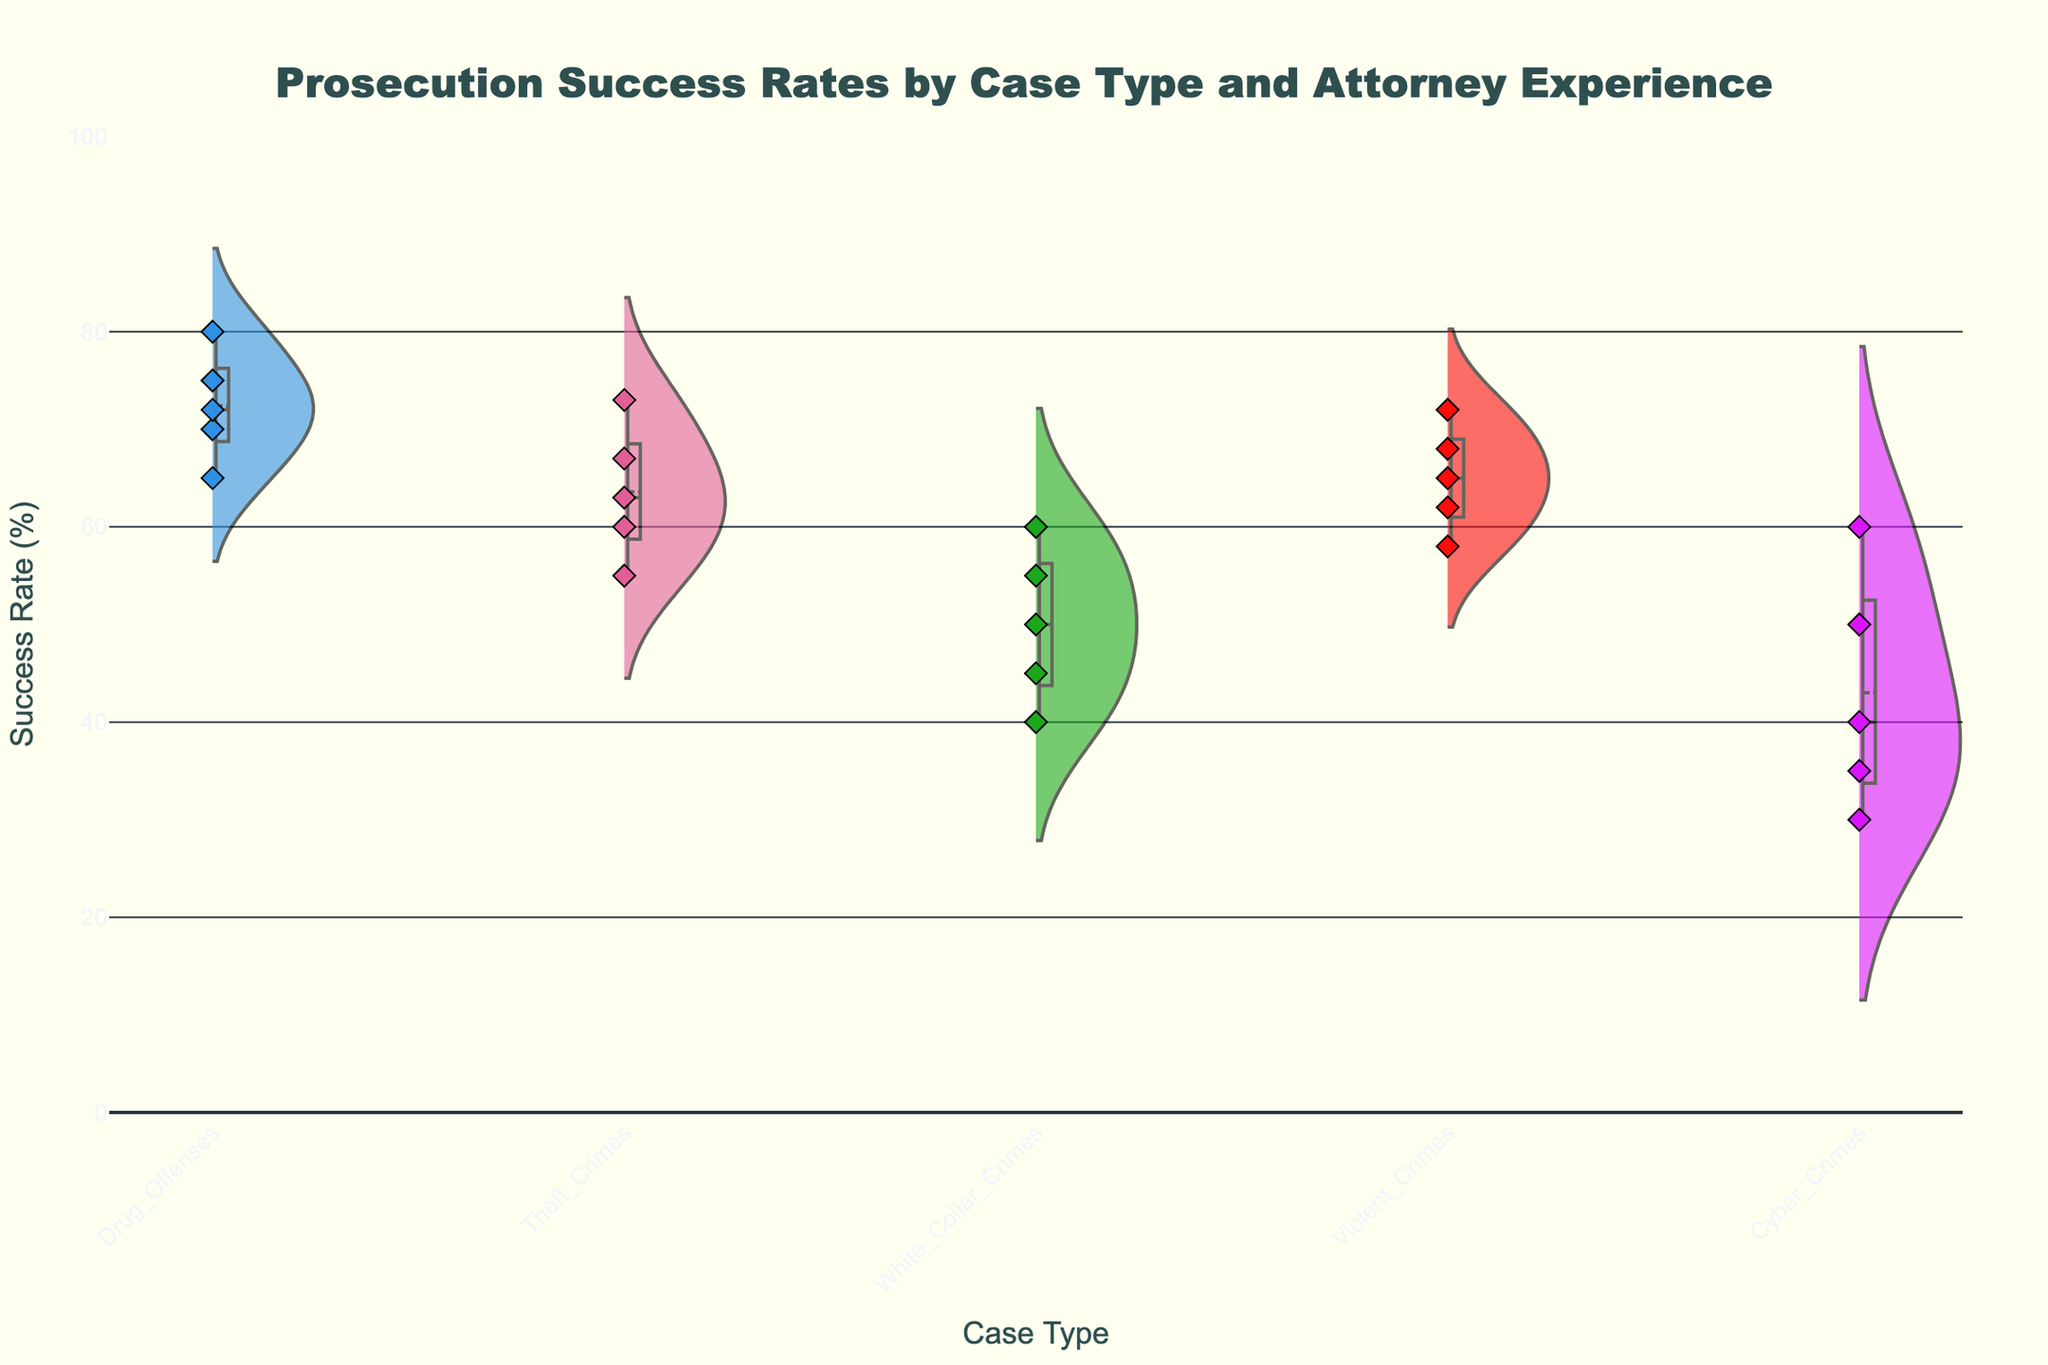what is the title of the figure? The title is located at the top center of the figure. It reads "Prosecution Success Rates by Case Type and Attorney Experience."
Answer: Prosecution Success Rates by Case Type and Attorney Experience What is the y-axis title? The y-axis title is labeled on the vertical axis of the figure. It reads "Success Rate (%)".
Answer: Success Rate (%) Which case type has the highest prosecution success rate? By looking at the top of the violin plots, the highest success rate appears in the "Drug Offenses" case type.
Answer: Drug Offenses How do the success rates for violent crimes compare to those for theft crimes? The violin plot for "Violent Crimes" shows a higher distribution and a higher mean success rate compared to the "Theft Crimes". The approximate range for "Violent Crimes" is 58%-72%, whereas for "Theft Crimes," it is 55%-73%.
Answer: Violent Crimes are generally higher What case type has the widest spread in prosecution success rates? The width of the violin plots represents the spread of the data. "Cyber Crimes" appears to have the widest spread, ranging from 30% to 60%.
Answer: Cyber Crimes What is the success rate for a 3-year experienced attorney handling white-collar crimes? Hovering over the jittered points (diamond symbols), the data for 3 years of experience in "White_Collar_Crimes" shows a success rate of 50%.
Answer: 50% Which case type shows the lowest starting success rate for 1-year experienced attorneys? By looking at the lowest point of the jittered points for "1 year", "Cyber_Crimes" has the lowest starting success rate at 30%.
Answer: Cyber Crimes Which case type has the steadiest increase in success rates relative to attorney experience? Observing the spacing between the jittered points, "Drug_Offenses" case type shows a consistent and steady increase in success rates as attorney experience increases from 1 year to 10 years.
Answer: Drug Offenses What is the mean success rate for theft crimes? The mean success rate is indicated by a line inside the violin plot for "Theft Crimes." The line is around 64%.
Answer: 64% Compare the success rate of a 10-year experienced attorney in violent crimes versus cyber crimes. By inspecting the jittered points, for 10-year experience, "Violent Crimes" success rate is around 72%, while "Cyber Crimes" success rate is around 60%. This shows "Violent Crimes" has a higher success rate.
Answer: Violent Crimes are higher 